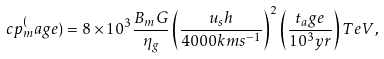Convert formula to latex. <formula><loc_0><loc_0><loc_500><loc_500>c p _ { m } ^ { ( } a g e ) = 8 \times 1 0 ^ { 3 } \frac { B _ { m } G } { \eta _ { g } } \left ( \frac { u _ { s } h } { 4 0 0 0 k m s ^ { - 1 } } \right ) ^ { 2 } \left ( \frac { t _ { a } g e } { 1 0 ^ { 3 } y r } \right ) T e V ,</formula> 